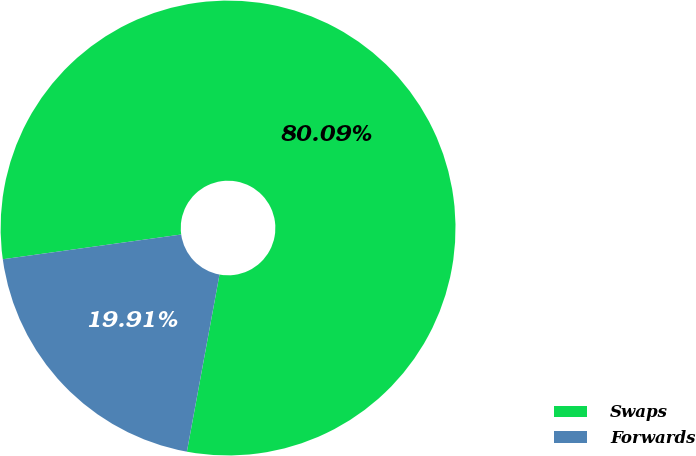<chart> <loc_0><loc_0><loc_500><loc_500><pie_chart><fcel>Swaps<fcel>Forwards<nl><fcel>80.09%<fcel>19.91%<nl></chart> 